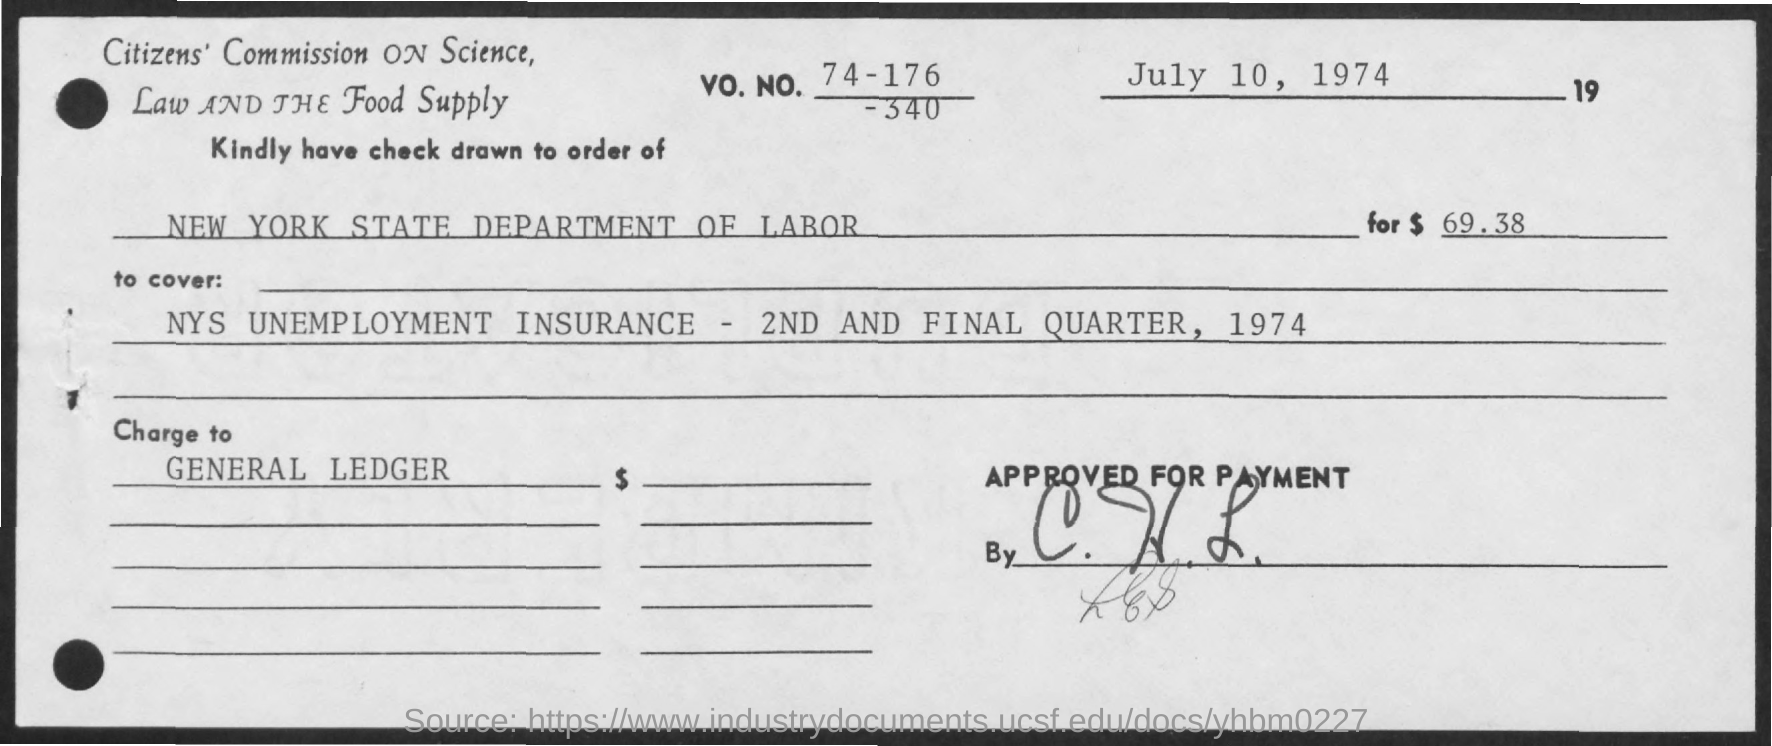What is the date mentioned in the given check ?
Provide a short and direct response. July 10, 1974. What is the vo.no. mentioned in the given check ?
Provide a short and direct response. 74-176-340. To what department the check has to be drawn ?
Ensure brevity in your answer.  New york state department of labor. 